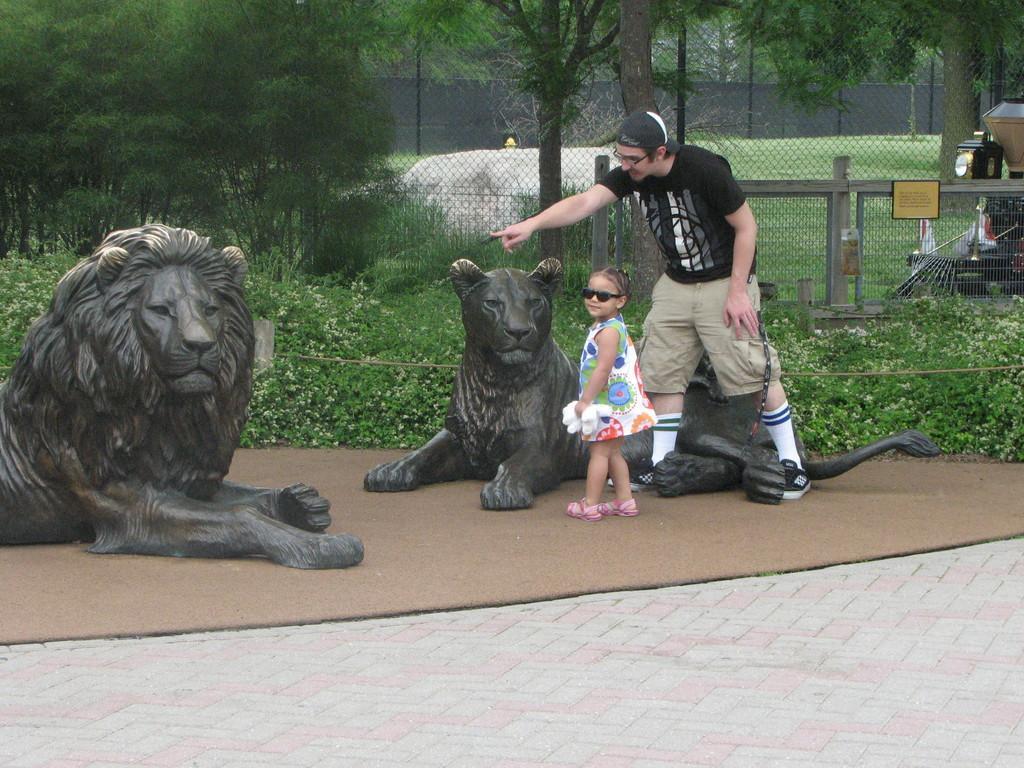Describe this image in one or two sentences. In the picture there are two lion statues and there is a kid and a man standing beside one of the statue and behind them there are some plants and trees and in the background there is a mesh and behind the mesh on the right side there is some object, it looks like some equipment. 